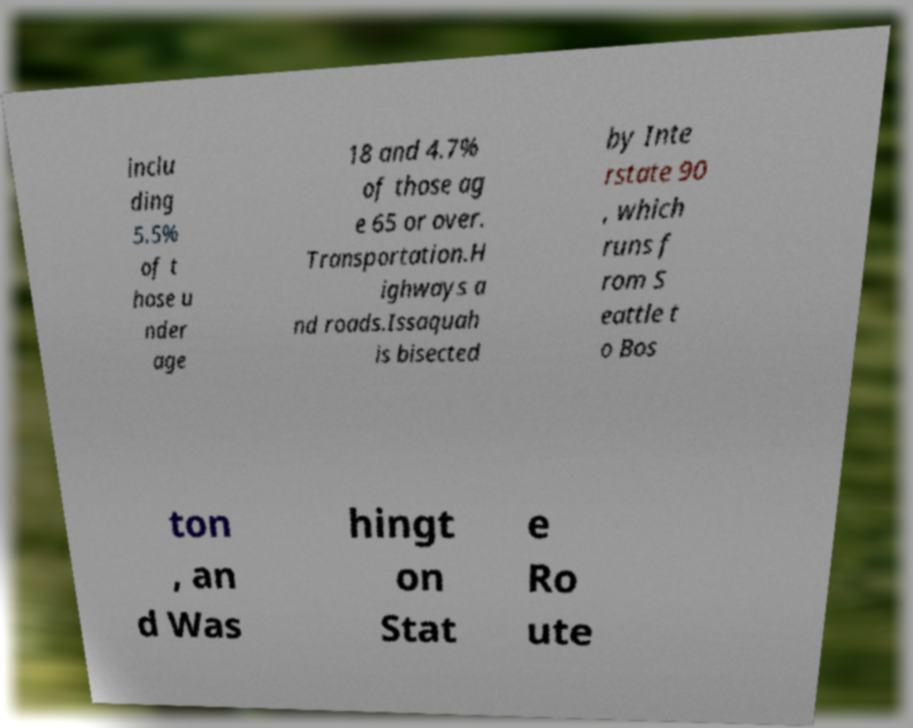I need the written content from this picture converted into text. Can you do that? inclu ding 5.5% of t hose u nder age 18 and 4.7% of those ag e 65 or over. Transportation.H ighways a nd roads.Issaquah is bisected by Inte rstate 90 , which runs f rom S eattle t o Bos ton , an d Was hingt on Stat e Ro ute 